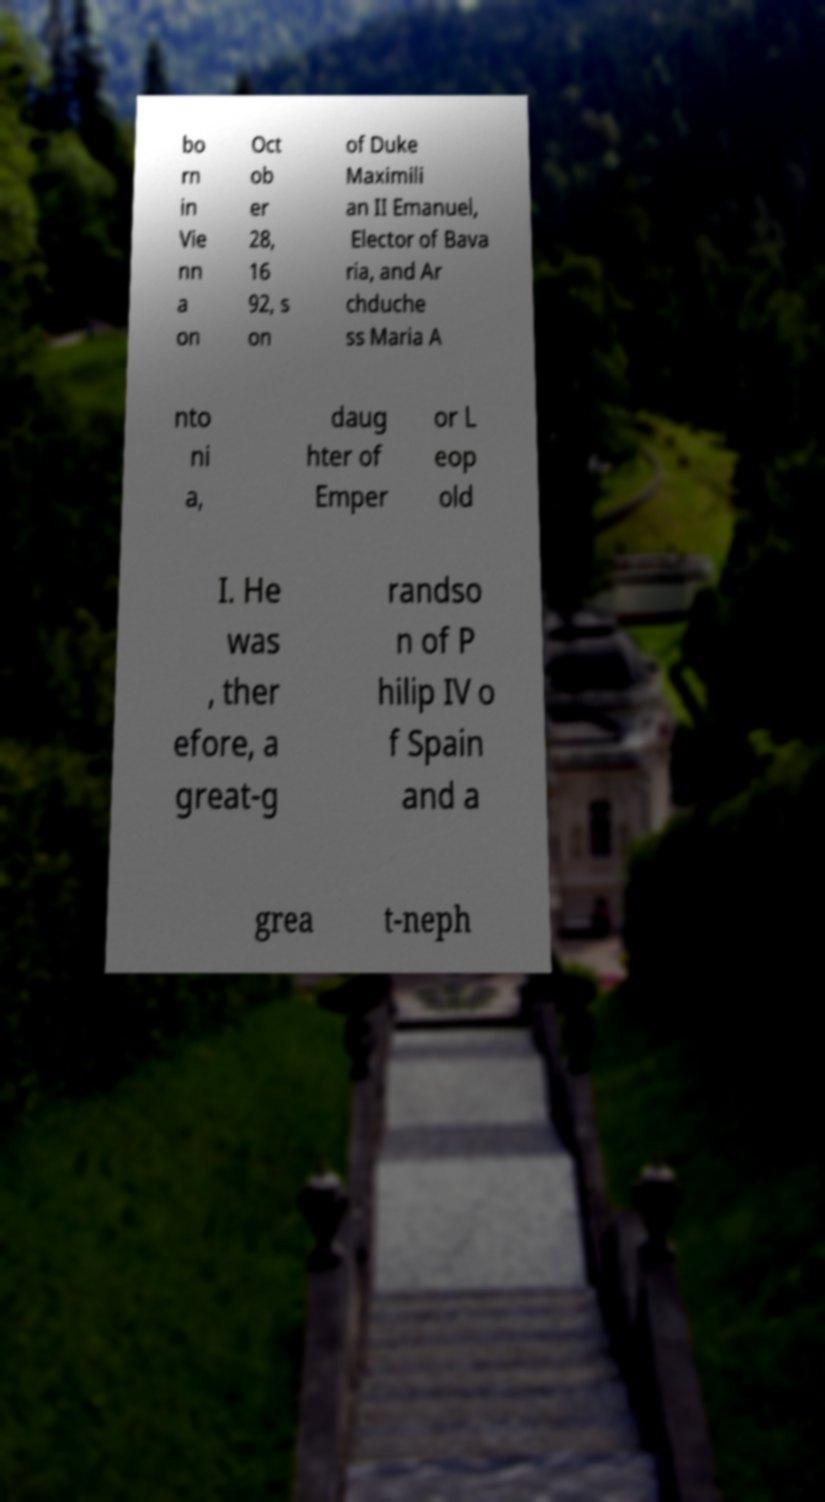Could you assist in decoding the text presented in this image and type it out clearly? bo rn in Vie nn a on Oct ob er 28, 16 92, s on of Duke Maximili an II Emanuel, Elector of Bava ria, and Ar chduche ss Maria A nto ni a, daug hter of Emper or L eop old I. He was , ther efore, a great-g randso n of P hilip IV o f Spain and a grea t-neph 